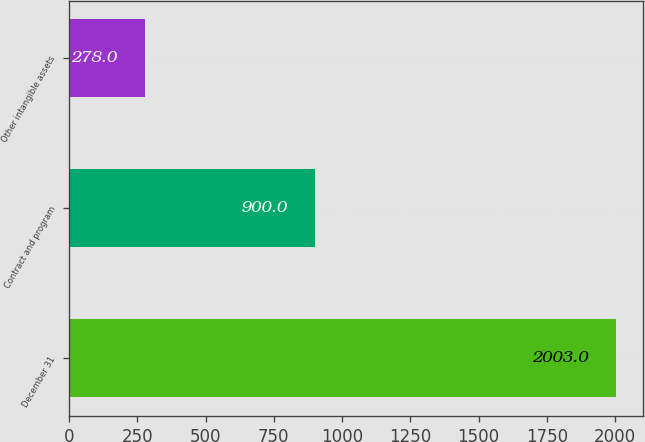Convert chart to OTSL. <chart><loc_0><loc_0><loc_500><loc_500><bar_chart><fcel>December 31<fcel>Contract and program<fcel>Other intangible assets<nl><fcel>2003<fcel>900<fcel>278<nl></chart> 